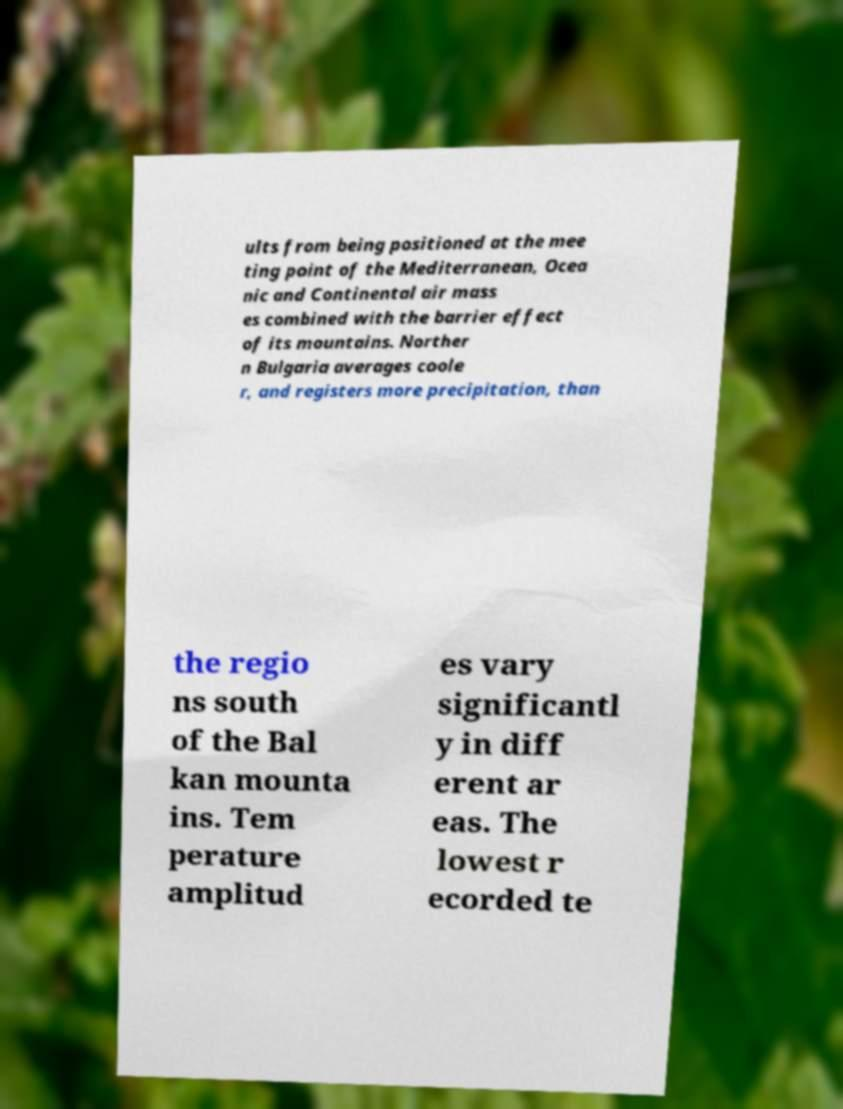Please identify and transcribe the text found in this image. ults from being positioned at the mee ting point of the Mediterranean, Ocea nic and Continental air mass es combined with the barrier effect of its mountains. Norther n Bulgaria averages coole r, and registers more precipitation, than the regio ns south of the Bal kan mounta ins. Tem perature amplitud es vary significantl y in diff erent ar eas. The lowest r ecorded te 